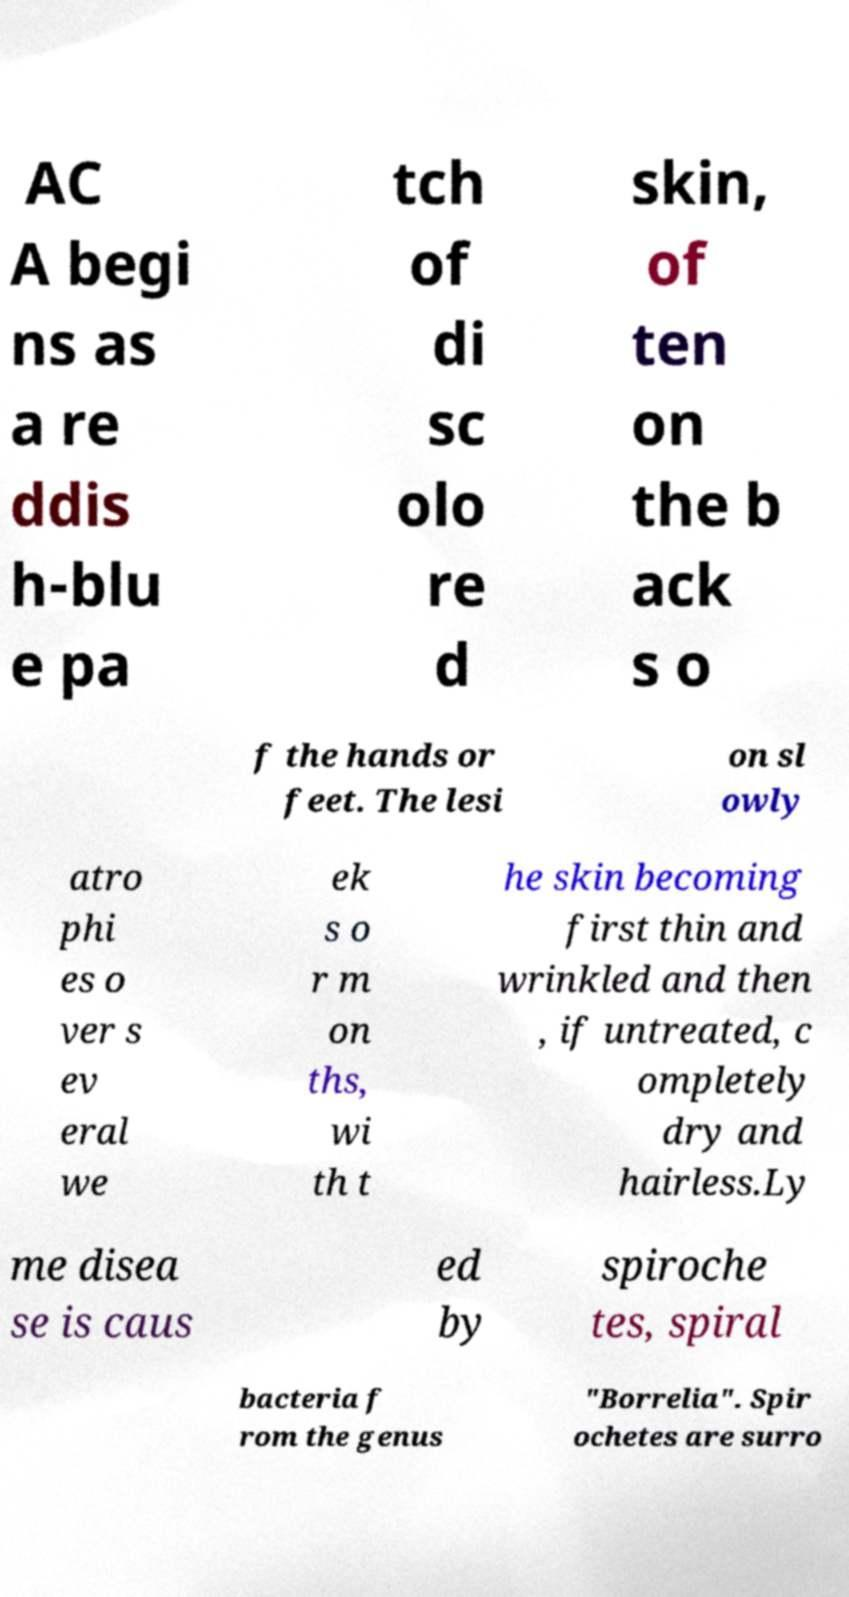For documentation purposes, I need the text within this image transcribed. Could you provide that? AC A begi ns as a re ddis h-blu e pa tch of di sc olo re d skin, of ten on the b ack s o f the hands or feet. The lesi on sl owly atro phi es o ver s ev eral we ek s o r m on ths, wi th t he skin becoming first thin and wrinkled and then , if untreated, c ompletely dry and hairless.Ly me disea se is caus ed by spiroche tes, spiral bacteria f rom the genus "Borrelia". Spir ochetes are surro 